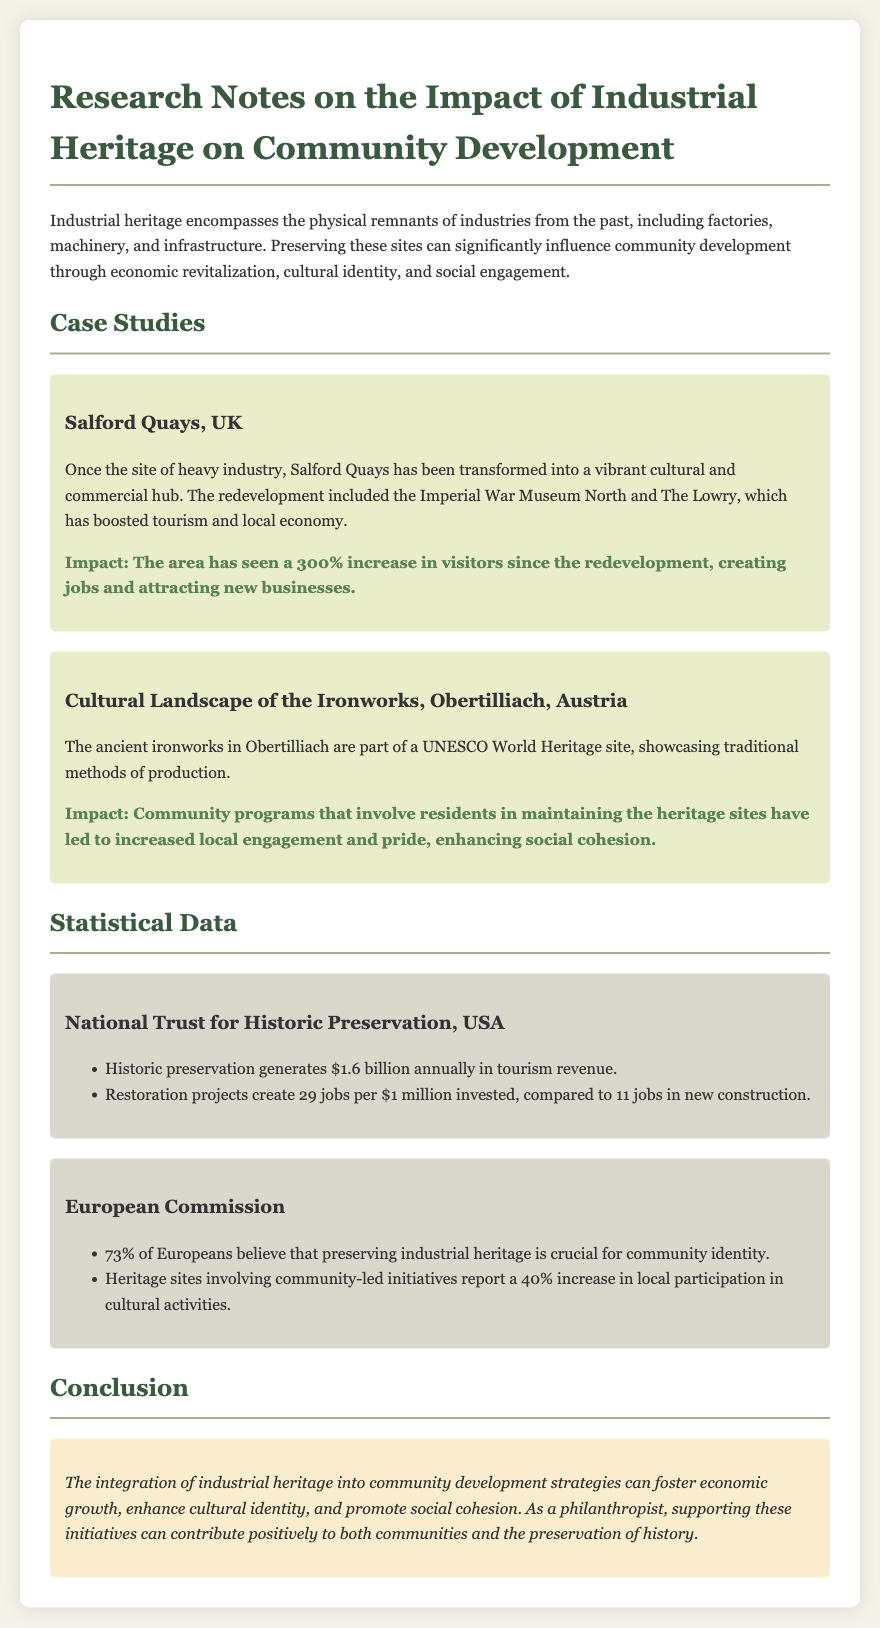What is the increase in visitors to Salford Quays after redevelopment? The document states that there has been a 300% increase in visitors since the redevelopment of Salford Quays.
Answer: 300% What is the annual tourism revenue generated by historic preservation in the USA? The document mentions that historic preservation generates $1.6 billion annually in tourism revenue.
Answer: $1.6 billion What percentage of Europeans believe preserving industrial heritage is crucial for community identity? According to the document, 73% of Europeans believe preserving industrial heritage is crucial for community identity.
Answer: 73% What is the number of jobs created per $1 million invested in restoration projects? The document states that restoration projects create 29 jobs per $1 million invested.
Answer: 29 What cultural institution is mentioned in the case study of Salford Quays? The Imperial War Museum North is mentioned as one of the institutions that boosted tourism in Salford Quays.
Answer: Imperial War Museum North How do community-led initiatives impact local participation in cultural activities? The document indicates that heritage sites involving community-led initiatives report a 40% increase in local participation in cultural activities.
Answer: 40% What is the main conclusion drawn from the document regarding industrial heritage? The integration of industrial heritage into community development strategies fosters economic growth and enhances cultural identity.
Answer: Economic growth and cultural identity What does the case study of Obertilliach highlight about community engagement? It shows that community programs involving residents in maintaining heritage sites enhance social cohesion.
Answer: Social cohesion 